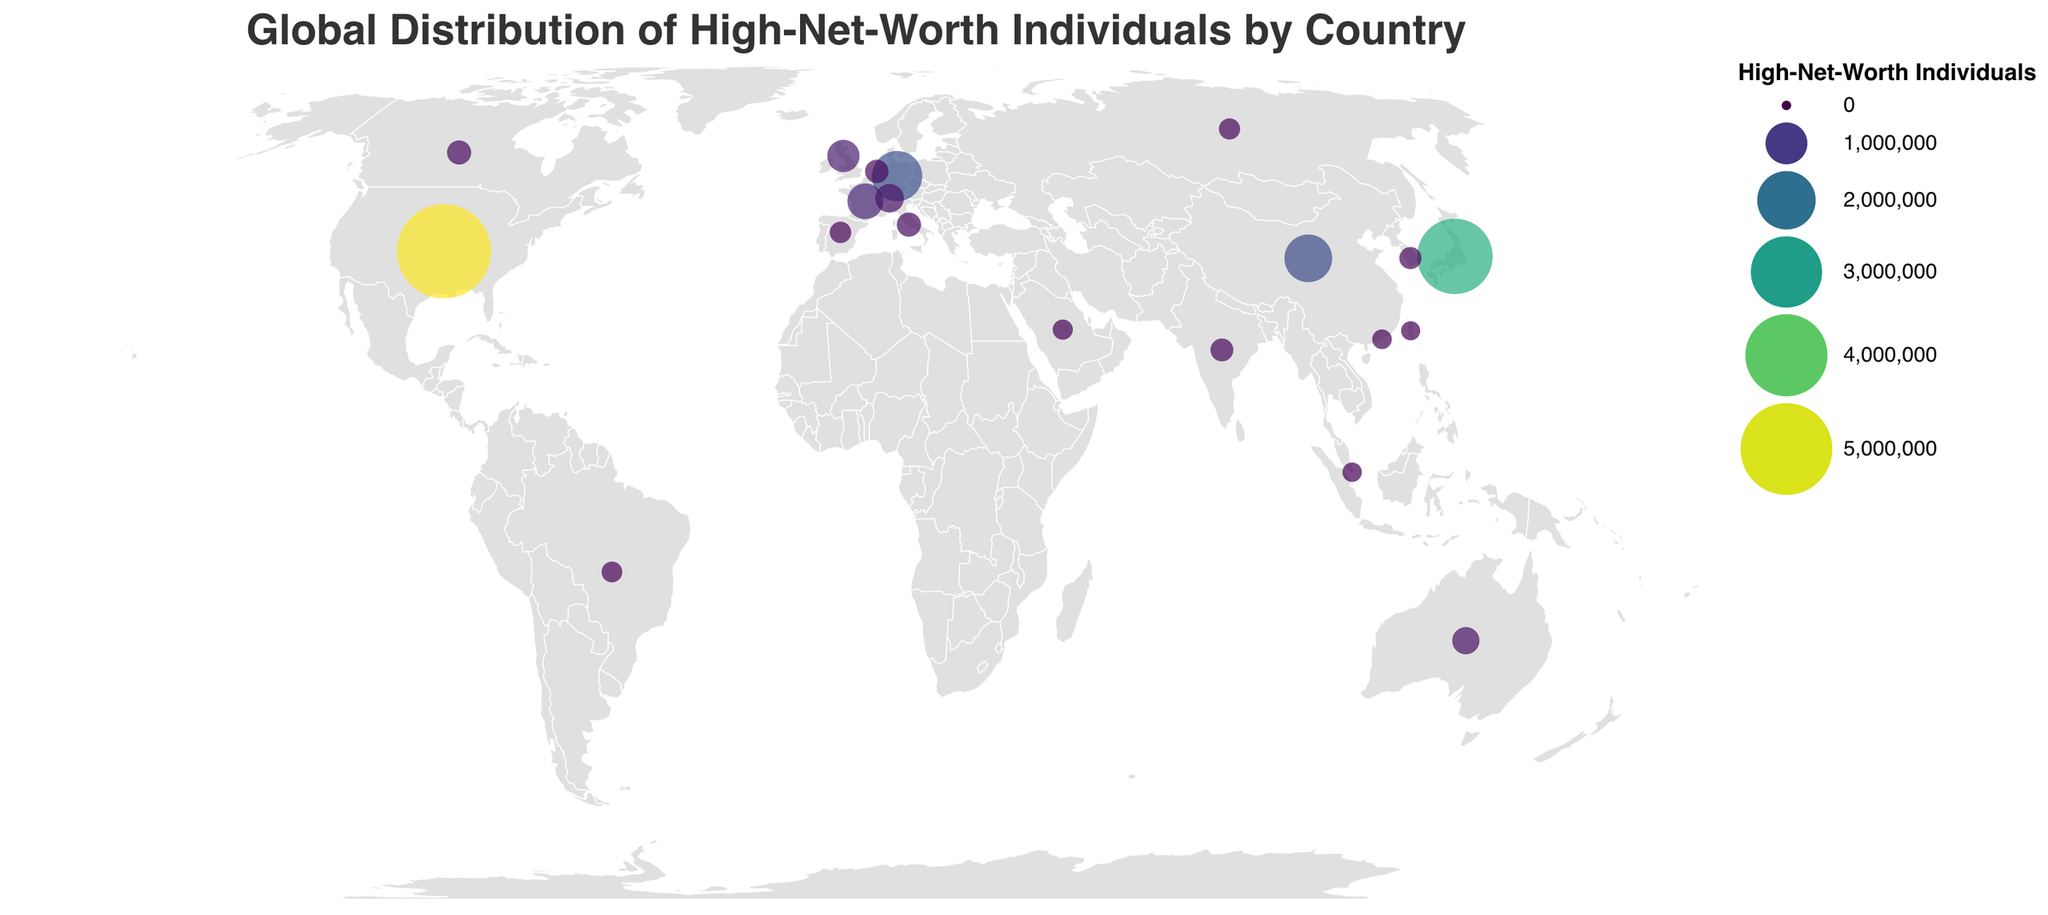What is the title of the figure? The title of the figure can be found at the top of the chart and it's written in a large font size for emphasis.
Answer: Global Distribution of High-Net-Worth Individuals by Country Which country has the highest number of high-net-worth individuals? The country with the largest circle corresponds to the country with the highest number of high-net-worth individuals.
Answer: United States Compare the number of high-net-worth individuals in Japan and Germany. Which country has more, and by how many? To find out which country has more high-net-worth individuals, compare the values next to 'Japan' and 'Germany' and subtract the smaller value from the larger one. Japan has 3,366,000 and Germany has 1,466,000, so 3,366,000 - 1,466,000 = 1,900,000.
Answer: Japan, by 1,900,000 What is the total number of high-net-worth individuals in the top 3 countries combined? Add the number of high-net-worth individuals in the United States, Japan, and China. United States: 5,285,000, Japan: 3,366,000, China: 1,314,000. Sum them: 5,285,000 + 3,366,000 + 1,314,000 = 9,965,000.
Answer: 9,965,000 How many countries have more than 500,000 high-net-worth individuals? Count the countries with circles representing more than 500,000 high-net-worth individuals. These are the United States, China, Japan, Germany, France, and the United Kingdom.
Answer: 6 Which country in Europe has the smallest number of high-net-worth individuals, and what is that number? Look for the smallest circle size representing a European country. Spain has the smallest number within Europe with 224,000 individuals.
Answer: Spain, 224,000 Compare the high-net-worth individual numbers between France and the United Kingdom. Which country has fewer, and by how much? Compare the numbers next to 'France' and 'United Kingdom'. France has 714,000 and the United Kingdom has 573,000. Subtract the smaller value from the larger: 714,000 - 573,000 = 141,000.
Answer: United Kingdom, by 141,000 Which country in the Southern Hemisphere has the highest number of high-net-worth individuals? Identify the circle with the highest number located below the equator. Australia has 392,000 high-net-worth individuals, which is the highest in the Southern Hemisphere.
Answer: Australia What is the median number of high-net-worth individuals among these countries? To find the median, list all the countries' high-net-worth individual counts in ascending order and find the middle value. Ordered values: 168,000, 174,000, 179,000, 192,000, 207,000, 218,000, 224,000, 243,000, 263,000, 278,000, 298,000, 298,000, 392,000, 438,000, 573,000, 714,000, 1314000, 1466000, 3366000, 5285000. The median is the average of the 10th and 11th values: (278,000 + 298,000)/2 = 288,000.
Answer: 288,000 